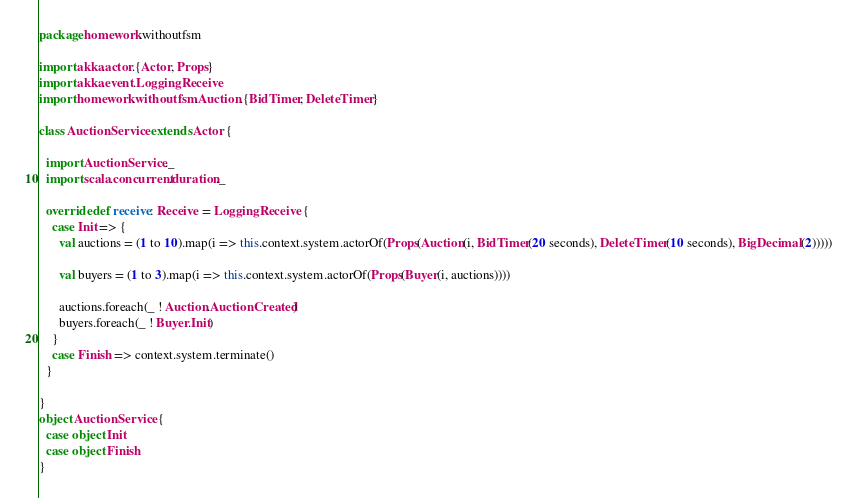<code> <loc_0><loc_0><loc_500><loc_500><_Scala_>package homework.withoutfsm

import akka.actor.{Actor, Props}
import akka.event.LoggingReceive
import homework.withoutfsm.Auction.{BidTimer, DeleteTimer}

class AuctionService extends Actor {

  import AuctionService._
  import scala.concurrent.duration._

  override def receive: Receive = LoggingReceive {
    case Init => {
      val auctions = (1 to 10).map(i => this.context.system.actorOf(Props(Auction(i, BidTimer(20 seconds), DeleteTimer(10 seconds), BigDecimal(2)))))

      val buyers = (1 to 3).map(i => this.context.system.actorOf(Props(Buyer(i, auctions))))

      auctions.foreach(_ ! Auction.AuctionCreated)
      buyers.foreach(_ ! Buyer.Init)
    }
    case Finish => context.system.terminate()
  }

}
object AuctionService {
  case object Init
  case object Finish
}</code> 